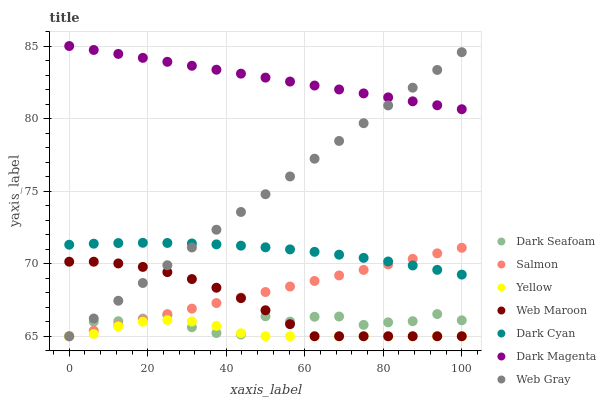Does Yellow have the minimum area under the curve?
Answer yes or no. Yes. Does Dark Magenta have the maximum area under the curve?
Answer yes or no. Yes. Does Salmon have the minimum area under the curve?
Answer yes or no. No. Does Salmon have the maximum area under the curve?
Answer yes or no. No. Is Dark Magenta the smoothest?
Answer yes or no. Yes. Is Dark Seafoam the roughest?
Answer yes or no. Yes. Is Web Maroon the smoothest?
Answer yes or no. No. Is Web Maroon the roughest?
Answer yes or no. No. Does Web Gray have the lowest value?
Answer yes or no. Yes. Does Dark Magenta have the lowest value?
Answer yes or no. No. Does Dark Magenta have the highest value?
Answer yes or no. Yes. Does Salmon have the highest value?
Answer yes or no. No. Is Web Maroon less than Dark Cyan?
Answer yes or no. Yes. Is Dark Magenta greater than Dark Seafoam?
Answer yes or no. Yes. Does Web Gray intersect Yellow?
Answer yes or no. Yes. Is Web Gray less than Yellow?
Answer yes or no. No. Is Web Gray greater than Yellow?
Answer yes or no. No. Does Web Maroon intersect Dark Cyan?
Answer yes or no. No. 